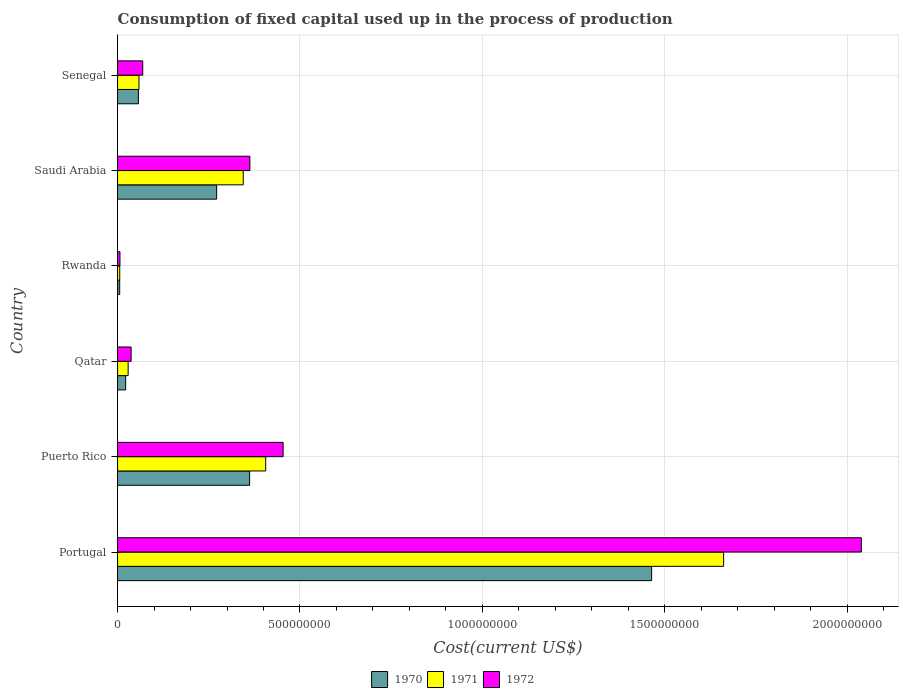What is the label of the 4th group of bars from the top?
Your response must be concise. Qatar. What is the amount consumed in the process of production in 1971 in Rwanda?
Offer a very short reply. 5.99e+06. Across all countries, what is the maximum amount consumed in the process of production in 1970?
Provide a succinct answer. 1.46e+09. Across all countries, what is the minimum amount consumed in the process of production in 1970?
Offer a very short reply. 5.84e+06. In which country was the amount consumed in the process of production in 1972 minimum?
Keep it short and to the point. Rwanda. What is the total amount consumed in the process of production in 1970 in the graph?
Ensure brevity in your answer.  2.18e+09. What is the difference between the amount consumed in the process of production in 1972 in Portugal and that in Senegal?
Offer a terse response. 1.97e+09. What is the difference between the amount consumed in the process of production in 1971 in Rwanda and the amount consumed in the process of production in 1972 in Puerto Rico?
Your answer should be compact. -4.48e+08. What is the average amount consumed in the process of production in 1972 per country?
Offer a terse response. 4.95e+08. What is the difference between the amount consumed in the process of production in 1970 and amount consumed in the process of production in 1971 in Senegal?
Offer a very short reply. -1.55e+06. What is the ratio of the amount consumed in the process of production in 1970 in Puerto Rico to that in Senegal?
Offer a very short reply. 6.34. Is the difference between the amount consumed in the process of production in 1970 in Portugal and Senegal greater than the difference between the amount consumed in the process of production in 1971 in Portugal and Senegal?
Ensure brevity in your answer.  No. What is the difference between the highest and the second highest amount consumed in the process of production in 1971?
Your response must be concise. 1.26e+09. What is the difference between the highest and the lowest amount consumed in the process of production in 1970?
Provide a succinct answer. 1.46e+09. Is the sum of the amount consumed in the process of production in 1971 in Puerto Rico and Senegal greater than the maximum amount consumed in the process of production in 1972 across all countries?
Provide a succinct answer. No. Is it the case that in every country, the sum of the amount consumed in the process of production in 1971 and amount consumed in the process of production in 1970 is greater than the amount consumed in the process of production in 1972?
Offer a terse response. Yes. How many countries are there in the graph?
Make the answer very short. 6. What is the difference between two consecutive major ticks on the X-axis?
Your answer should be compact. 5.00e+08. Are the values on the major ticks of X-axis written in scientific E-notation?
Give a very brief answer. No. Does the graph contain grids?
Ensure brevity in your answer.  Yes. Where does the legend appear in the graph?
Keep it short and to the point. Bottom center. How many legend labels are there?
Give a very brief answer. 3. What is the title of the graph?
Make the answer very short. Consumption of fixed capital used up in the process of production. Does "1962" appear as one of the legend labels in the graph?
Your response must be concise. No. What is the label or title of the X-axis?
Give a very brief answer. Cost(current US$). What is the label or title of the Y-axis?
Give a very brief answer. Country. What is the Cost(current US$) of 1970 in Portugal?
Provide a short and direct response. 1.46e+09. What is the Cost(current US$) in 1971 in Portugal?
Provide a succinct answer. 1.66e+09. What is the Cost(current US$) of 1972 in Portugal?
Offer a terse response. 2.04e+09. What is the Cost(current US$) in 1970 in Puerto Rico?
Provide a succinct answer. 3.62e+08. What is the Cost(current US$) of 1971 in Puerto Rico?
Your answer should be compact. 4.06e+08. What is the Cost(current US$) in 1972 in Puerto Rico?
Offer a very short reply. 4.54e+08. What is the Cost(current US$) of 1970 in Qatar?
Keep it short and to the point. 2.22e+07. What is the Cost(current US$) of 1971 in Qatar?
Ensure brevity in your answer.  2.90e+07. What is the Cost(current US$) in 1972 in Qatar?
Keep it short and to the point. 3.72e+07. What is the Cost(current US$) of 1970 in Rwanda?
Give a very brief answer. 5.84e+06. What is the Cost(current US$) of 1971 in Rwanda?
Your answer should be compact. 5.99e+06. What is the Cost(current US$) in 1972 in Rwanda?
Give a very brief answer. 6.56e+06. What is the Cost(current US$) in 1970 in Saudi Arabia?
Provide a short and direct response. 2.72e+08. What is the Cost(current US$) in 1971 in Saudi Arabia?
Give a very brief answer. 3.44e+08. What is the Cost(current US$) of 1972 in Saudi Arabia?
Keep it short and to the point. 3.63e+08. What is the Cost(current US$) of 1970 in Senegal?
Offer a terse response. 5.71e+07. What is the Cost(current US$) of 1971 in Senegal?
Provide a succinct answer. 5.87e+07. What is the Cost(current US$) in 1972 in Senegal?
Offer a terse response. 6.90e+07. Across all countries, what is the maximum Cost(current US$) in 1970?
Ensure brevity in your answer.  1.46e+09. Across all countries, what is the maximum Cost(current US$) in 1971?
Make the answer very short. 1.66e+09. Across all countries, what is the maximum Cost(current US$) in 1972?
Make the answer very short. 2.04e+09. Across all countries, what is the minimum Cost(current US$) in 1970?
Offer a terse response. 5.84e+06. Across all countries, what is the minimum Cost(current US$) of 1971?
Provide a succinct answer. 5.99e+06. Across all countries, what is the minimum Cost(current US$) of 1972?
Provide a succinct answer. 6.56e+06. What is the total Cost(current US$) of 1970 in the graph?
Offer a terse response. 2.18e+09. What is the total Cost(current US$) of 1971 in the graph?
Offer a terse response. 2.51e+09. What is the total Cost(current US$) of 1972 in the graph?
Make the answer very short. 2.97e+09. What is the difference between the Cost(current US$) of 1970 in Portugal and that in Puerto Rico?
Provide a short and direct response. 1.10e+09. What is the difference between the Cost(current US$) in 1971 in Portugal and that in Puerto Rico?
Ensure brevity in your answer.  1.26e+09. What is the difference between the Cost(current US$) of 1972 in Portugal and that in Puerto Rico?
Provide a succinct answer. 1.58e+09. What is the difference between the Cost(current US$) of 1970 in Portugal and that in Qatar?
Keep it short and to the point. 1.44e+09. What is the difference between the Cost(current US$) of 1971 in Portugal and that in Qatar?
Your response must be concise. 1.63e+09. What is the difference between the Cost(current US$) in 1972 in Portugal and that in Qatar?
Give a very brief answer. 2.00e+09. What is the difference between the Cost(current US$) in 1970 in Portugal and that in Rwanda?
Your answer should be very brief. 1.46e+09. What is the difference between the Cost(current US$) in 1971 in Portugal and that in Rwanda?
Offer a terse response. 1.66e+09. What is the difference between the Cost(current US$) in 1972 in Portugal and that in Rwanda?
Keep it short and to the point. 2.03e+09. What is the difference between the Cost(current US$) of 1970 in Portugal and that in Saudi Arabia?
Your response must be concise. 1.19e+09. What is the difference between the Cost(current US$) in 1971 in Portugal and that in Saudi Arabia?
Your answer should be very brief. 1.32e+09. What is the difference between the Cost(current US$) in 1972 in Portugal and that in Saudi Arabia?
Make the answer very short. 1.68e+09. What is the difference between the Cost(current US$) of 1970 in Portugal and that in Senegal?
Your response must be concise. 1.41e+09. What is the difference between the Cost(current US$) in 1971 in Portugal and that in Senegal?
Keep it short and to the point. 1.60e+09. What is the difference between the Cost(current US$) of 1972 in Portugal and that in Senegal?
Provide a short and direct response. 1.97e+09. What is the difference between the Cost(current US$) in 1970 in Puerto Rico and that in Qatar?
Offer a very short reply. 3.40e+08. What is the difference between the Cost(current US$) in 1971 in Puerto Rico and that in Qatar?
Your answer should be very brief. 3.77e+08. What is the difference between the Cost(current US$) in 1972 in Puerto Rico and that in Qatar?
Provide a short and direct response. 4.17e+08. What is the difference between the Cost(current US$) in 1970 in Puerto Rico and that in Rwanda?
Keep it short and to the point. 3.56e+08. What is the difference between the Cost(current US$) of 1971 in Puerto Rico and that in Rwanda?
Your response must be concise. 4.00e+08. What is the difference between the Cost(current US$) of 1972 in Puerto Rico and that in Rwanda?
Offer a terse response. 4.47e+08. What is the difference between the Cost(current US$) of 1970 in Puerto Rico and that in Saudi Arabia?
Provide a succinct answer. 9.04e+07. What is the difference between the Cost(current US$) of 1971 in Puerto Rico and that in Saudi Arabia?
Provide a succinct answer. 6.15e+07. What is the difference between the Cost(current US$) in 1972 in Puerto Rico and that in Saudi Arabia?
Ensure brevity in your answer.  9.11e+07. What is the difference between the Cost(current US$) of 1970 in Puerto Rico and that in Senegal?
Offer a very short reply. 3.05e+08. What is the difference between the Cost(current US$) in 1971 in Puerto Rico and that in Senegal?
Keep it short and to the point. 3.47e+08. What is the difference between the Cost(current US$) in 1972 in Puerto Rico and that in Senegal?
Keep it short and to the point. 3.85e+08. What is the difference between the Cost(current US$) of 1970 in Qatar and that in Rwanda?
Keep it short and to the point. 1.63e+07. What is the difference between the Cost(current US$) in 1971 in Qatar and that in Rwanda?
Provide a short and direct response. 2.30e+07. What is the difference between the Cost(current US$) in 1972 in Qatar and that in Rwanda?
Your answer should be very brief. 3.06e+07. What is the difference between the Cost(current US$) of 1970 in Qatar and that in Saudi Arabia?
Give a very brief answer. -2.49e+08. What is the difference between the Cost(current US$) in 1971 in Qatar and that in Saudi Arabia?
Your answer should be compact. -3.15e+08. What is the difference between the Cost(current US$) of 1972 in Qatar and that in Saudi Arabia?
Provide a succinct answer. -3.25e+08. What is the difference between the Cost(current US$) in 1970 in Qatar and that in Senegal?
Your answer should be very brief. -3.50e+07. What is the difference between the Cost(current US$) of 1971 in Qatar and that in Senegal?
Make the answer very short. -2.97e+07. What is the difference between the Cost(current US$) of 1972 in Qatar and that in Senegal?
Your answer should be compact. -3.18e+07. What is the difference between the Cost(current US$) of 1970 in Rwanda and that in Saudi Arabia?
Your answer should be compact. -2.66e+08. What is the difference between the Cost(current US$) in 1971 in Rwanda and that in Saudi Arabia?
Ensure brevity in your answer.  -3.38e+08. What is the difference between the Cost(current US$) in 1972 in Rwanda and that in Saudi Arabia?
Ensure brevity in your answer.  -3.56e+08. What is the difference between the Cost(current US$) of 1970 in Rwanda and that in Senegal?
Your answer should be very brief. -5.13e+07. What is the difference between the Cost(current US$) in 1971 in Rwanda and that in Senegal?
Keep it short and to the point. -5.27e+07. What is the difference between the Cost(current US$) in 1972 in Rwanda and that in Senegal?
Make the answer very short. -6.24e+07. What is the difference between the Cost(current US$) in 1970 in Saudi Arabia and that in Senegal?
Give a very brief answer. 2.14e+08. What is the difference between the Cost(current US$) in 1971 in Saudi Arabia and that in Senegal?
Your answer should be compact. 2.86e+08. What is the difference between the Cost(current US$) in 1972 in Saudi Arabia and that in Senegal?
Make the answer very short. 2.94e+08. What is the difference between the Cost(current US$) in 1970 in Portugal and the Cost(current US$) in 1971 in Puerto Rico?
Give a very brief answer. 1.06e+09. What is the difference between the Cost(current US$) of 1970 in Portugal and the Cost(current US$) of 1972 in Puerto Rico?
Your response must be concise. 1.01e+09. What is the difference between the Cost(current US$) in 1971 in Portugal and the Cost(current US$) in 1972 in Puerto Rico?
Offer a terse response. 1.21e+09. What is the difference between the Cost(current US$) in 1970 in Portugal and the Cost(current US$) in 1971 in Qatar?
Your response must be concise. 1.43e+09. What is the difference between the Cost(current US$) of 1970 in Portugal and the Cost(current US$) of 1972 in Qatar?
Make the answer very short. 1.43e+09. What is the difference between the Cost(current US$) in 1971 in Portugal and the Cost(current US$) in 1972 in Qatar?
Give a very brief answer. 1.62e+09. What is the difference between the Cost(current US$) of 1970 in Portugal and the Cost(current US$) of 1971 in Rwanda?
Give a very brief answer. 1.46e+09. What is the difference between the Cost(current US$) of 1970 in Portugal and the Cost(current US$) of 1972 in Rwanda?
Keep it short and to the point. 1.46e+09. What is the difference between the Cost(current US$) in 1971 in Portugal and the Cost(current US$) in 1972 in Rwanda?
Your response must be concise. 1.65e+09. What is the difference between the Cost(current US$) in 1970 in Portugal and the Cost(current US$) in 1971 in Saudi Arabia?
Your answer should be very brief. 1.12e+09. What is the difference between the Cost(current US$) in 1970 in Portugal and the Cost(current US$) in 1972 in Saudi Arabia?
Your answer should be compact. 1.10e+09. What is the difference between the Cost(current US$) in 1971 in Portugal and the Cost(current US$) in 1972 in Saudi Arabia?
Offer a terse response. 1.30e+09. What is the difference between the Cost(current US$) of 1970 in Portugal and the Cost(current US$) of 1971 in Senegal?
Offer a terse response. 1.41e+09. What is the difference between the Cost(current US$) of 1970 in Portugal and the Cost(current US$) of 1972 in Senegal?
Give a very brief answer. 1.39e+09. What is the difference between the Cost(current US$) in 1971 in Portugal and the Cost(current US$) in 1972 in Senegal?
Ensure brevity in your answer.  1.59e+09. What is the difference between the Cost(current US$) of 1970 in Puerto Rico and the Cost(current US$) of 1971 in Qatar?
Give a very brief answer. 3.33e+08. What is the difference between the Cost(current US$) in 1970 in Puerto Rico and the Cost(current US$) in 1972 in Qatar?
Provide a short and direct response. 3.25e+08. What is the difference between the Cost(current US$) of 1971 in Puerto Rico and the Cost(current US$) of 1972 in Qatar?
Provide a short and direct response. 3.69e+08. What is the difference between the Cost(current US$) of 1970 in Puerto Rico and the Cost(current US$) of 1971 in Rwanda?
Offer a very short reply. 3.56e+08. What is the difference between the Cost(current US$) in 1970 in Puerto Rico and the Cost(current US$) in 1972 in Rwanda?
Offer a terse response. 3.55e+08. What is the difference between the Cost(current US$) of 1971 in Puerto Rico and the Cost(current US$) of 1972 in Rwanda?
Ensure brevity in your answer.  3.99e+08. What is the difference between the Cost(current US$) in 1970 in Puerto Rico and the Cost(current US$) in 1971 in Saudi Arabia?
Your answer should be very brief. 1.75e+07. What is the difference between the Cost(current US$) in 1970 in Puerto Rico and the Cost(current US$) in 1972 in Saudi Arabia?
Your answer should be very brief. -6.36e+05. What is the difference between the Cost(current US$) in 1971 in Puerto Rico and the Cost(current US$) in 1972 in Saudi Arabia?
Provide a short and direct response. 4.33e+07. What is the difference between the Cost(current US$) in 1970 in Puerto Rico and the Cost(current US$) in 1971 in Senegal?
Provide a succinct answer. 3.03e+08. What is the difference between the Cost(current US$) in 1970 in Puerto Rico and the Cost(current US$) in 1972 in Senegal?
Keep it short and to the point. 2.93e+08. What is the difference between the Cost(current US$) of 1971 in Puerto Rico and the Cost(current US$) of 1972 in Senegal?
Make the answer very short. 3.37e+08. What is the difference between the Cost(current US$) of 1970 in Qatar and the Cost(current US$) of 1971 in Rwanda?
Provide a short and direct response. 1.62e+07. What is the difference between the Cost(current US$) of 1970 in Qatar and the Cost(current US$) of 1972 in Rwanda?
Give a very brief answer. 1.56e+07. What is the difference between the Cost(current US$) in 1971 in Qatar and the Cost(current US$) in 1972 in Rwanda?
Offer a terse response. 2.24e+07. What is the difference between the Cost(current US$) of 1970 in Qatar and the Cost(current US$) of 1971 in Saudi Arabia?
Make the answer very short. -3.22e+08. What is the difference between the Cost(current US$) of 1970 in Qatar and the Cost(current US$) of 1972 in Saudi Arabia?
Make the answer very short. -3.40e+08. What is the difference between the Cost(current US$) in 1971 in Qatar and the Cost(current US$) in 1972 in Saudi Arabia?
Provide a short and direct response. -3.34e+08. What is the difference between the Cost(current US$) of 1970 in Qatar and the Cost(current US$) of 1971 in Senegal?
Your response must be concise. -3.65e+07. What is the difference between the Cost(current US$) of 1970 in Qatar and the Cost(current US$) of 1972 in Senegal?
Give a very brief answer. -4.68e+07. What is the difference between the Cost(current US$) of 1971 in Qatar and the Cost(current US$) of 1972 in Senegal?
Offer a terse response. -4.00e+07. What is the difference between the Cost(current US$) of 1970 in Rwanda and the Cost(current US$) of 1971 in Saudi Arabia?
Your answer should be compact. -3.39e+08. What is the difference between the Cost(current US$) in 1970 in Rwanda and the Cost(current US$) in 1972 in Saudi Arabia?
Your answer should be very brief. -3.57e+08. What is the difference between the Cost(current US$) in 1971 in Rwanda and the Cost(current US$) in 1972 in Saudi Arabia?
Offer a terse response. -3.57e+08. What is the difference between the Cost(current US$) of 1970 in Rwanda and the Cost(current US$) of 1971 in Senegal?
Keep it short and to the point. -5.29e+07. What is the difference between the Cost(current US$) of 1970 in Rwanda and the Cost(current US$) of 1972 in Senegal?
Provide a succinct answer. -6.31e+07. What is the difference between the Cost(current US$) in 1971 in Rwanda and the Cost(current US$) in 1972 in Senegal?
Your answer should be compact. -6.30e+07. What is the difference between the Cost(current US$) of 1970 in Saudi Arabia and the Cost(current US$) of 1971 in Senegal?
Offer a terse response. 2.13e+08. What is the difference between the Cost(current US$) in 1970 in Saudi Arabia and the Cost(current US$) in 1972 in Senegal?
Your response must be concise. 2.03e+08. What is the difference between the Cost(current US$) in 1971 in Saudi Arabia and the Cost(current US$) in 1972 in Senegal?
Keep it short and to the point. 2.75e+08. What is the average Cost(current US$) in 1970 per country?
Your answer should be compact. 3.64e+08. What is the average Cost(current US$) of 1971 per country?
Your response must be concise. 4.18e+08. What is the average Cost(current US$) of 1972 per country?
Your response must be concise. 4.95e+08. What is the difference between the Cost(current US$) of 1970 and Cost(current US$) of 1971 in Portugal?
Provide a short and direct response. -1.97e+08. What is the difference between the Cost(current US$) in 1970 and Cost(current US$) in 1972 in Portugal?
Your answer should be very brief. -5.75e+08. What is the difference between the Cost(current US$) of 1971 and Cost(current US$) of 1972 in Portugal?
Your answer should be very brief. -3.77e+08. What is the difference between the Cost(current US$) of 1970 and Cost(current US$) of 1971 in Puerto Rico?
Your answer should be compact. -4.40e+07. What is the difference between the Cost(current US$) of 1970 and Cost(current US$) of 1972 in Puerto Rico?
Offer a very short reply. -9.18e+07. What is the difference between the Cost(current US$) of 1971 and Cost(current US$) of 1972 in Puerto Rico?
Give a very brief answer. -4.78e+07. What is the difference between the Cost(current US$) in 1970 and Cost(current US$) in 1971 in Qatar?
Your response must be concise. -6.81e+06. What is the difference between the Cost(current US$) in 1970 and Cost(current US$) in 1972 in Qatar?
Give a very brief answer. -1.50e+07. What is the difference between the Cost(current US$) in 1971 and Cost(current US$) in 1972 in Qatar?
Offer a terse response. -8.20e+06. What is the difference between the Cost(current US$) in 1970 and Cost(current US$) in 1971 in Rwanda?
Provide a succinct answer. -1.47e+05. What is the difference between the Cost(current US$) of 1970 and Cost(current US$) of 1972 in Rwanda?
Your response must be concise. -7.15e+05. What is the difference between the Cost(current US$) of 1971 and Cost(current US$) of 1972 in Rwanda?
Provide a succinct answer. -5.68e+05. What is the difference between the Cost(current US$) in 1970 and Cost(current US$) in 1971 in Saudi Arabia?
Your answer should be compact. -7.29e+07. What is the difference between the Cost(current US$) in 1970 and Cost(current US$) in 1972 in Saudi Arabia?
Give a very brief answer. -9.11e+07. What is the difference between the Cost(current US$) in 1971 and Cost(current US$) in 1972 in Saudi Arabia?
Give a very brief answer. -1.81e+07. What is the difference between the Cost(current US$) of 1970 and Cost(current US$) of 1971 in Senegal?
Offer a terse response. -1.55e+06. What is the difference between the Cost(current US$) of 1970 and Cost(current US$) of 1972 in Senegal?
Provide a succinct answer. -1.18e+07. What is the difference between the Cost(current US$) in 1971 and Cost(current US$) in 1972 in Senegal?
Provide a short and direct response. -1.03e+07. What is the ratio of the Cost(current US$) in 1970 in Portugal to that in Puerto Rico?
Offer a very short reply. 4.04. What is the ratio of the Cost(current US$) of 1971 in Portugal to that in Puerto Rico?
Ensure brevity in your answer.  4.09. What is the ratio of the Cost(current US$) in 1972 in Portugal to that in Puerto Rico?
Provide a short and direct response. 4.49. What is the ratio of the Cost(current US$) of 1970 in Portugal to that in Qatar?
Provide a succinct answer. 65.97. What is the ratio of the Cost(current US$) in 1971 in Portugal to that in Qatar?
Your answer should be compact. 57.29. What is the ratio of the Cost(current US$) in 1972 in Portugal to that in Qatar?
Keep it short and to the point. 54.81. What is the ratio of the Cost(current US$) of 1970 in Portugal to that in Rwanda?
Your answer should be very brief. 250.6. What is the ratio of the Cost(current US$) of 1971 in Portugal to that in Rwanda?
Your response must be concise. 277.38. What is the ratio of the Cost(current US$) of 1972 in Portugal to that in Rwanda?
Offer a very short reply. 310.91. What is the ratio of the Cost(current US$) in 1970 in Portugal to that in Saudi Arabia?
Provide a short and direct response. 5.39. What is the ratio of the Cost(current US$) in 1971 in Portugal to that in Saudi Arabia?
Give a very brief answer. 4.82. What is the ratio of the Cost(current US$) of 1972 in Portugal to that in Saudi Arabia?
Make the answer very short. 5.62. What is the ratio of the Cost(current US$) in 1970 in Portugal to that in Senegal?
Keep it short and to the point. 25.62. What is the ratio of the Cost(current US$) of 1971 in Portugal to that in Senegal?
Your answer should be compact. 28.3. What is the ratio of the Cost(current US$) in 1972 in Portugal to that in Senegal?
Your answer should be very brief. 29.55. What is the ratio of the Cost(current US$) in 1970 in Puerto Rico to that in Qatar?
Provide a short and direct response. 16.31. What is the ratio of the Cost(current US$) in 1971 in Puerto Rico to that in Qatar?
Ensure brevity in your answer.  14. What is the ratio of the Cost(current US$) in 1972 in Puerto Rico to that in Qatar?
Your answer should be very brief. 12.2. What is the ratio of the Cost(current US$) of 1970 in Puerto Rico to that in Rwanda?
Offer a terse response. 61.97. What is the ratio of the Cost(current US$) of 1971 in Puerto Rico to that in Rwanda?
Give a very brief answer. 67.79. What is the ratio of the Cost(current US$) in 1972 in Puerto Rico to that in Rwanda?
Ensure brevity in your answer.  69.21. What is the ratio of the Cost(current US$) of 1970 in Puerto Rico to that in Saudi Arabia?
Make the answer very short. 1.33. What is the ratio of the Cost(current US$) of 1971 in Puerto Rico to that in Saudi Arabia?
Your answer should be very brief. 1.18. What is the ratio of the Cost(current US$) of 1972 in Puerto Rico to that in Saudi Arabia?
Ensure brevity in your answer.  1.25. What is the ratio of the Cost(current US$) of 1970 in Puerto Rico to that in Senegal?
Offer a very short reply. 6.34. What is the ratio of the Cost(current US$) in 1971 in Puerto Rico to that in Senegal?
Give a very brief answer. 6.92. What is the ratio of the Cost(current US$) of 1972 in Puerto Rico to that in Senegal?
Offer a terse response. 6.58. What is the ratio of the Cost(current US$) in 1970 in Qatar to that in Rwanda?
Offer a very short reply. 3.8. What is the ratio of the Cost(current US$) in 1971 in Qatar to that in Rwanda?
Your response must be concise. 4.84. What is the ratio of the Cost(current US$) of 1972 in Qatar to that in Rwanda?
Your answer should be very brief. 5.67. What is the ratio of the Cost(current US$) in 1970 in Qatar to that in Saudi Arabia?
Offer a very short reply. 0.08. What is the ratio of the Cost(current US$) in 1971 in Qatar to that in Saudi Arabia?
Keep it short and to the point. 0.08. What is the ratio of the Cost(current US$) of 1972 in Qatar to that in Saudi Arabia?
Keep it short and to the point. 0.1. What is the ratio of the Cost(current US$) of 1970 in Qatar to that in Senegal?
Give a very brief answer. 0.39. What is the ratio of the Cost(current US$) of 1971 in Qatar to that in Senegal?
Keep it short and to the point. 0.49. What is the ratio of the Cost(current US$) of 1972 in Qatar to that in Senegal?
Make the answer very short. 0.54. What is the ratio of the Cost(current US$) of 1970 in Rwanda to that in Saudi Arabia?
Provide a short and direct response. 0.02. What is the ratio of the Cost(current US$) in 1971 in Rwanda to that in Saudi Arabia?
Provide a short and direct response. 0.02. What is the ratio of the Cost(current US$) in 1972 in Rwanda to that in Saudi Arabia?
Offer a terse response. 0.02. What is the ratio of the Cost(current US$) in 1970 in Rwanda to that in Senegal?
Keep it short and to the point. 0.1. What is the ratio of the Cost(current US$) of 1971 in Rwanda to that in Senegal?
Provide a short and direct response. 0.1. What is the ratio of the Cost(current US$) in 1972 in Rwanda to that in Senegal?
Your response must be concise. 0.1. What is the ratio of the Cost(current US$) of 1970 in Saudi Arabia to that in Senegal?
Keep it short and to the point. 4.75. What is the ratio of the Cost(current US$) of 1971 in Saudi Arabia to that in Senegal?
Make the answer very short. 5.87. What is the ratio of the Cost(current US$) in 1972 in Saudi Arabia to that in Senegal?
Give a very brief answer. 5.26. What is the difference between the highest and the second highest Cost(current US$) in 1970?
Offer a very short reply. 1.10e+09. What is the difference between the highest and the second highest Cost(current US$) in 1971?
Your response must be concise. 1.26e+09. What is the difference between the highest and the second highest Cost(current US$) in 1972?
Make the answer very short. 1.58e+09. What is the difference between the highest and the lowest Cost(current US$) in 1970?
Provide a succinct answer. 1.46e+09. What is the difference between the highest and the lowest Cost(current US$) in 1971?
Make the answer very short. 1.66e+09. What is the difference between the highest and the lowest Cost(current US$) in 1972?
Your answer should be compact. 2.03e+09. 